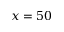<formula> <loc_0><loc_0><loc_500><loc_500>x = 5 0</formula> 